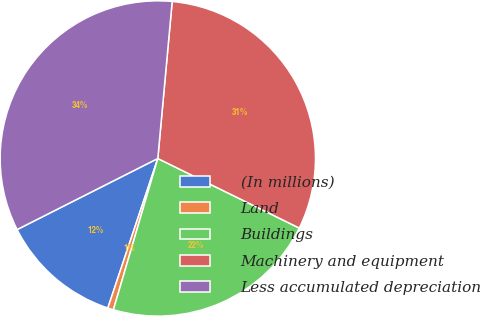Convert chart. <chart><loc_0><loc_0><loc_500><loc_500><pie_chart><fcel>(In millions)<fcel>Land<fcel>Buildings<fcel>Machinery and equipment<fcel>Less accumulated depreciation<nl><fcel>12.42%<fcel>0.59%<fcel>22.27%<fcel>30.82%<fcel>33.9%<nl></chart> 